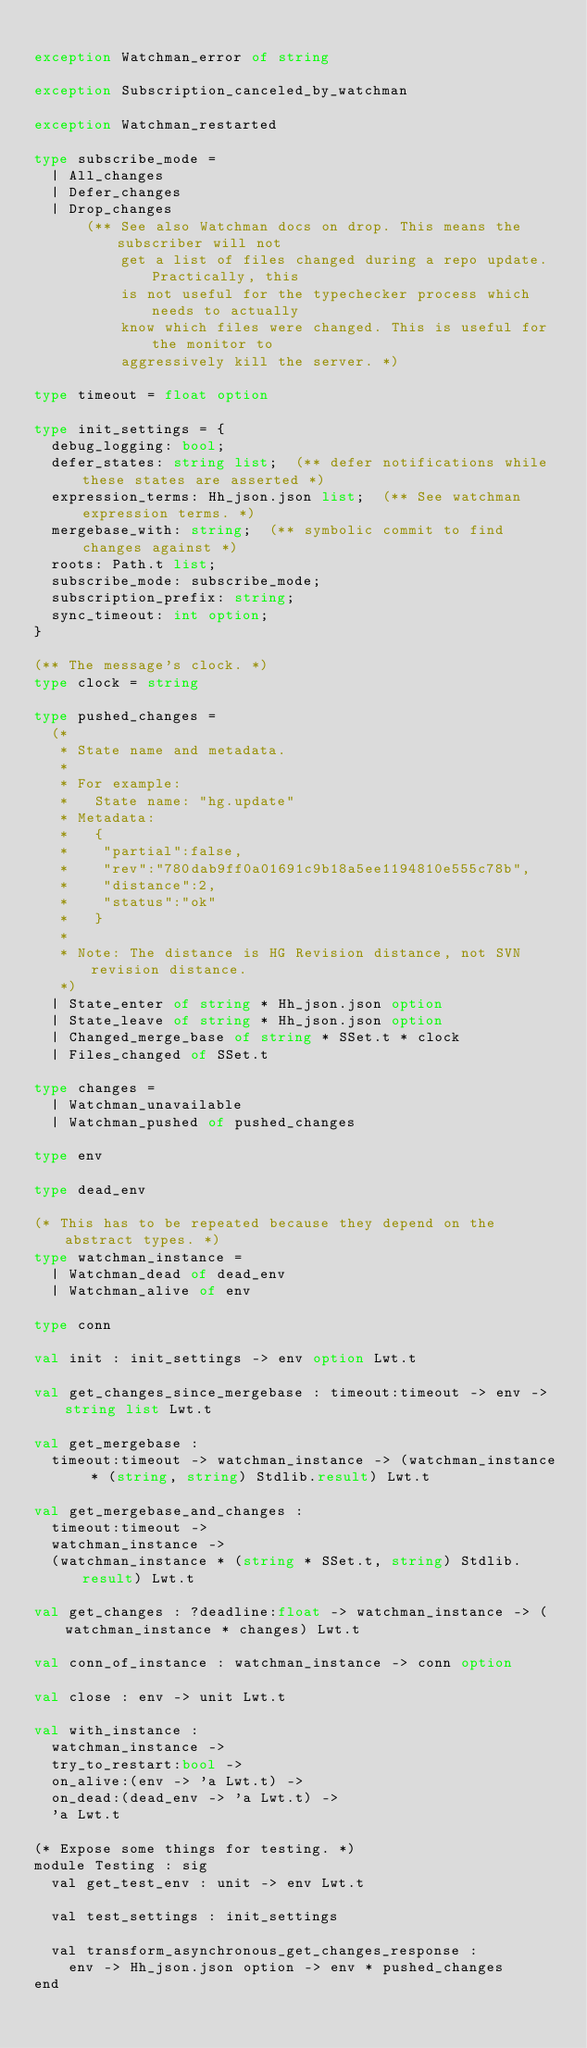Convert code to text. <code><loc_0><loc_0><loc_500><loc_500><_OCaml_>
exception Watchman_error of string

exception Subscription_canceled_by_watchman

exception Watchman_restarted

type subscribe_mode =
  | All_changes
  | Defer_changes
  | Drop_changes
      (** See also Watchman docs on drop. This means the subscriber will not
          get a list of files changed during a repo update. Practically, this
          is not useful for the typechecker process which needs to actually
          know which files were changed. This is useful for the monitor to
          aggressively kill the server. *)

type timeout = float option

type init_settings = {
  debug_logging: bool;
  defer_states: string list;  (** defer notifications while these states are asserted *)
  expression_terms: Hh_json.json list;  (** See watchman expression terms. *)
  mergebase_with: string;  (** symbolic commit to find changes against *)
  roots: Path.t list;
  subscribe_mode: subscribe_mode;
  subscription_prefix: string;
  sync_timeout: int option;
}

(** The message's clock. *)
type clock = string

type pushed_changes =
  (*
   * State name and metadata.
   *
   * For example:
   *   State name: "hg.update"
   * Metadata:
   *   {
   *    "partial":false,
   *    "rev":"780dab9ff0a01691c9b18a5ee1194810e555c78b",
   *    "distance":2,
   *    "status":"ok"
   *   }
   *
   * Note: The distance is HG Revision distance, not SVN revision distance.
   *)
  | State_enter of string * Hh_json.json option
  | State_leave of string * Hh_json.json option
  | Changed_merge_base of string * SSet.t * clock
  | Files_changed of SSet.t

type changes =
  | Watchman_unavailable
  | Watchman_pushed of pushed_changes

type env

type dead_env

(* This has to be repeated because they depend on the abstract types. *)
type watchman_instance =
  | Watchman_dead of dead_env
  | Watchman_alive of env

type conn

val init : init_settings -> env option Lwt.t

val get_changes_since_mergebase : timeout:timeout -> env -> string list Lwt.t

val get_mergebase :
  timeout:timeout -> watchman_instance -> (watchman_instance * (string, string) Stdlib.result) Lwt.t

val get_mergebase_and_changes :
  timeout:timeout ->
  watchman_instance ->
  (watchman_instance * (string * SSet.t, string) Stdlib.result) Lwt.t

val get_changes : ?deadline:float -> watchman_instance -> (watchman_instance * changes) Lwt.t

val conn_of_instance : watchman_instance -> conn option

val close : env -> unit Lwt.t

val with_instance :
  watchman_instance ->
  try_to_restart:bool ->
  on_alive:(env -> 'a Lwt.t) ->
  on_dead:(dead_env -> 'a Lwt.t) ->
  'a Lwt.t

(* Expose some things for testing. *)
module Testing : sig
  val get_test_env : unit -> env Lwt.t

  val test_settings : init_settings

  val transform_asynchronous_get_changes_response :
    env -> Hh_json.json option -> env * pushed_changes
end
</code> 